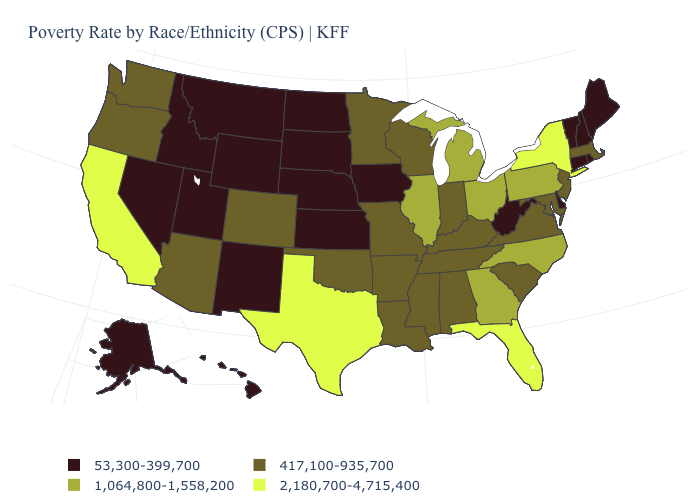What is the value of Virginia?
Answer briefly. 417,100-935,700. What is the value of South Carolina?
Write a very short answer. 417,100-935,700. Name the states that have a value in the range 417,100-935,700?
Write a very short answer. Alabama, Arizona, Arkansas, Colorado, Indiana, Kentucky, Louisiana, Maryland, Massachusetts, Minnesota, Mississippi, Missouri, New Jersey, Oklahoma, Oregon, South Carolina, Tennessee, Virginia, Washington, Wisconsin. What is the value of Ohio?
Write a very short answer. 1,064,800-1,558,200. Name the states that have a value in the range 1,064,800-1,558,200?
Short answer required. Georgia, Illinois, Michigan, North Carolina, Ohio, Pennsylvania. Name the states that have a value in the range 2,180,700-4,715,400?
Concise answer only. California, Florida, New York, Texas. What is the value of Oklahoma?
Keep it brief. 417,100-935,700. Does Colorado have the highest value in the West?
Quick response, please. No. Name the states that have a value in the range 53,300-399,700?
Keep it brief. Alaska, Connecticut, Delaware, Hawaii, Idaho, Iowa, Kansas, Maine, Montana, Nebraska, Nevada, New Hampshire, New Mexico, North Dakota, Rhode Island, South Dakota, Utah, Vermont, West Virginia, Wyoming. What is the highest value in the USA?
Concise answer only. 2,180,700-4,715,400. Name the states that have a value in the range 2,180,700-4,715,400?
Quick response, please. California, Florida, New York, Texas. Does Ohio have a higher value than Maine?
Be succinct. Yes. Name the states that have a value in the range 53,300-399,700?
Be succinct. Alaska, Connecticut, Delaware, Hawaii, Idaho, Iowa, Kansas, Maine, Montana, Nebraska, Nevada, New Hampshire, New Mexico, North Dakota, Rhode Island, South Dakota, Utah, Vermont, West Virginia, Wyoming. Does Utah have the same value as Pennsylvania?
Write a very short answer. No. Does Nebraska have the same value as Maryland?
Concise answer only. No. 